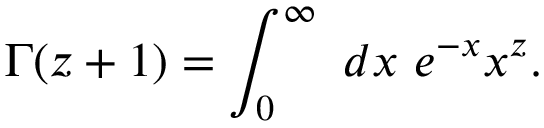<formula> <loc_0><loc_0><loc_500><loc_500>\Gamma ( z + 1 ) = \int _ { 0 } ^ { \infty } \, d x \, e ^ { - x } x ^ { z } .</formula> 